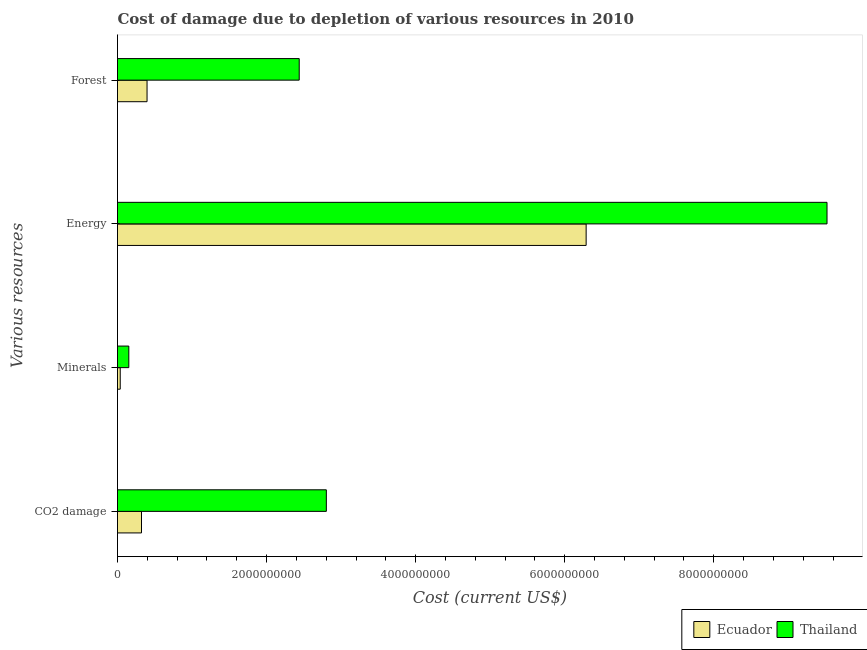How many different coloured bars are there?
Give a very brief answer. 2. How many groups of bars are there?
Offer a terse response. 4. Are the number of bars on each tick of the Y-axis equal?
Give a very brief answer. Yes. How many bars are there on the 1st tick from the top?
Provide a short and direct response. 2. What is the label of the 1st group of bars from the top?
Provide a short and direct response. Forest. What is the cost of damage due to depletion of energy in Ecuador?
Your response must be concise. 6.29e+09. Across all countries, what is the maximum cost of damage due to depletion of energy?
Provide a succinct answer. 9.52e+09. Across all countries, what is the minimum cost of damage due to depletion of forests?
Your answer should be very brief. 3.96e+08. In which country was the cost of damage due to depletion of coal maximum?
Keep it short and to the point. Thailand. In which country was the cost of damage due to depletion of energy minimum?
Offer a very short reply. Ecuador. What is the total cost of damage due to depletion of forests in the graph?
Your response must be concise. 2.83e+09. What is the difference between the cost of damage due to depletion of energy in Thailand and that in Ecuador?
Offer a terse response. 3.23e+09. What is the difference between the cost of damage due to depletion of energy in Ecuador and the cost of damage due to depletion of coal in Thailand?
Provide a succinct answer. 3.49e+09. What is the average cost of damage due to depletion of coal per country?
Provide a short and direct response. 1.56e+09. What is the difference between the cost of damage due to depletion of coal and cost of damage due to depletion of minerals in Thailand?
Ensure brevity in your answer.  2.65e+09. What is the ratio of the cost of damage due to depletion of forests in Thailand to that in Ecuador?
Your answer should be compact. 6.15. What is the difference between the highest and the second highest cost of damage due to depletion of energy?
Give a very brief answer. 3.23e+09. What is the difference between the highest and the lowest cost of damage due to depletion of forests?
Give a very brief answer. 2.04e+09. In how many countries, is the cost of damage due to depletion of coal greater than the average cost of damage due to depletion of coal taken over all countries?
Offer a terse response. 1. Is the sum of the cost of damage due to depletion of forests in Ecuador and Thailand greater than the maximum cost of damage due to depletion of coal across all countries?
Ensure brevity in your answer.  Yes. Is it the case that in every country, the sum of the cost of damage due to depletion of minerals and cost of damage due to depletion of energy is greater than the sum of cost of damage due to depletion of forests and cost of damage due to depletion of coal?
Offer a very short reply. No. What does the 1st bar from the top in Energy represents?
Give a very brief answer. Thailand. What does the 2nd bar from the bottom in Minerals represents?
Make the answer very short. Thailand. Is it the case that in every country, the sum of the cost of damage due to depletion of coal and cost of damage due to depletion of minerals is greater than the cost of damage due to depletion of energy?
Give a very brief answer. No. How many bars are there?
Provide a succinct answer. 8. Does the graph contain any zero values?
Your answer should be very brief. No. How are the legend labels stacked?
Keep it short and to the point. Horizontal. What is the title of the graph?
Offer a terse response. Cost of damage due to depletion of various resources in 2010 . Does "Namibia" appear as one of the legend labels in the graph?
Your response must be concise. No. What is the label or title of the X-axis?
Ensure brevity in your answer.  Cost (current US$). What is the label or title of the Y-axis?
Your response must be concise. Various resources. What is the Cost (current US$) in Ecuador in CO2 damage?
Offer a terse response. 3.22e+08. What is the Cost (current US$) of Thailand in CO2 damage?
Your response must be concise. 2.80e+09. What is the Cost (current US$) in Ecuador in Minerals?
Provide a short and direct response. 3.66e+07. What is the Cost (current US$) of Thailand in Minerals?
Ensure brevity in your answer.  1.52e+08. What is the Cost (current US$) in Ecuador in Energy?
Offer a very short reply. 6.29e+09. What is the Cost (current US$) of Thailand in Energy?
Provide a short and direct response. 9.52e+09. What is the Cost (current US$) in Ecuador in Forest?
Offer a terse response. 3.96e+08. What is the Cost (current US$) in Thailand in Forest?
Your response must be concise. 2.44e+09. Across all Various resources, what is the maximum Cost (current US$) in Ecuador?
Give a very brief answer. 6.29e+09. Across all Various resources, what is the maximum Cost (current US$) of Thailand?
Your response must be concise. 9.52e+09. Across all Various resources, what is the minimum Cost (current US$) of Ecuador?
Your answer should be very brief. 3.66e+07. Across all Various resources, what is the minimum Cost (current US$) of Thailand?
Make the answer very short. 1.52e+08. What is the total Cost (current US$) in Ecuador in the graph?
Offer a very short reply. 7.04e+09. What is the total Cost (current US$) of Thailand in the graph?
Your answer should be very brief. 1.49e+1. What is the difference between the Cost (current US$) in Ecuador in CO2 damage and that in Minerals?
Provide a succinct answer. 2.85e+08. What is the difference between the Cost (current US$) of Thailand in CO2 damage and that in Minerals?
Ensure brevity in your answer.  2.65e+09. What is the difference between the Cost (current US$) of Ecuador in CO2 damage and that in Energy?
Offer a terse response. -5.97e+09. What is the difference between the Cost (current US$) of Thailand in CO2 damage and that in Energy?
Offer a very short reply. -6.72e+09. What is the difference between the Cost (current US$) in Ecuador in CO2 damage and that in Forest?
Give a very brief answer. -7.45e+07. What is the difference between the Cost (current US$) in Thailand in CO2 damage and that in Forest?
Offer a very short reply. 3.64e+08. What is the difference between the Cost (current US$) in Ecuador in Minerals and that in Energy?
Provide a succinct answer. -6.25e+09. What is the difference between the Cost (current US$) in Thailand in Minerals and that in Energy?
Ensure brevity in your answer.  -9.37e+09. What is the difference between the Cost (current US$) in Ecuador in Minerals and that in Forest?
Your answer should be compact. -3.60e+08. What is the difference between the Cost (current US$) of Thailand in Minerals and that in Forest?
Make the answer very short. -2.29e+09. What is the difference between the Cost (current US$) in Ecuador in Energy and that in Forest?
Offer a very short reply. 5.89e+09. What is the difference between the Cost (current US$) of Thailand in Energy and that in Forest?
Give a very brief answer. 7.08e+09. What is the difference between the Cost (current US$) in Ecuador in CO2 damage and the Cost (current US$) in Thailand in Minerals?
Give a very brief answer. 1.70e+08. What is the difference between the Cost (current US$) of Ecuador in CO2 damage and the Cost (current US$) of Thailand in Energy?
Your answer should be compact. -9.20e+09. What is the difference between the Cost (current US$) in Ecuador in CO2 damage and the Cost (current US$) in Thailand in Forest?
Your response must be concise. -2.12e+09. What is the difference between the Cost (current US$) of Ecuador in Minerals and the Cost (current US$) of Thailand in Energy?
Ensure brevity in your answer.  -9.48e+09. What is the difference between the Cost (current US$) of Ecuador in Minerals and the Cost (current US$) of Thailand in Forest?
Keep it short and to the point. -2.40e+09. What is the difference between the Cost (current US$) of Ecuador in Energy and the Cost (current US$) of Thailand in Forest?
Ensure brevity in your answer.  3.85e+09. What is the average Cost (current US$) of Ecuador per Various resources?
Give a very brief answer. 1.76e+09. What is the average Cost (current US$) in Thailand per Various resources?
Ensure brevity in your answer.  3.73e+09. What is the difference between the Cost (current US$) in Ecuador and Cost (current US$) in Thailand in CO2 damage?
Ensure brevity in your answer.  -2.48e+09. What is the difference between the Cost (current US$) of Ecuador and Cost (current US$) of Thailand in Minerals?
Your answer should be compact. -1.15e+08. What is the difference between the Cost (current US$) in Ecuador and Cost (current US$) in Thailand in Energy?
Your answer should be compact. -3.23e+09. What is the difference between the Cost (current US$) of Ecuador and Cost (current US$) of Thailand in Forest?
Offer a terse response. -2.04e+09. What is the ratio of the Cost (current US$) of Ecuador in CO2 damage to that in Minerals?
Your answer should be very brief. 8.8. What is the ratio of the Cost (current US$) in Thailand in CO2 damage to that in Minerals?
Give a very brief answer. 18.46. What is the ratio of the Cost (current US$) in Ecuador in CO2 damage to that in Energy?
Offer a very short reply. 0.05. What is the ratio of the Cost (current US$) of Thailand in CO2 damage to that in Energy?
Provide a succinct answer. 0.29. What is the ratio of the Cost (current US$) in Ecuador in CO2 damage to that in Forest?
Give a very brief answer. 0.81. What is the ratio of the Cost (current US$) of Thailand in CO2 damage to that in Forest?
Your response must be concise. 1.15. What is the ratio of the Cost (current US$) of Ecuador in Minerals to that in Energy?
Your answer should be compact. 0.01. What is the ratio of the Cost (current US$) in Thailand in Minerals to that in Energy?
Keep it short and to the point. 0.02. What is the ratio of the Cost (current US$) of Ecuador in Minerals to that in Forest?
Offer a terse response. 0.09. What is the ratio of the Cost (current US$) in Thailand in Minerals to that in Forest?
Your answer should be compact. 0.06. What is the ratio of the Cost (current US$) in Ecuador in Energy to that in Forest?
Offer a terse response. 15.86. What is the ratio of the Cost (current US$) in Thailand in Energy to that in Forest?
Keep it short and to the point. 3.9. What is the difference between the highest and the second highest Cost (current US$) of Ecuador?
Your response must be concise. 5.89e+09. What is the difference between the highest and the second highest Cost (current US$) in Thailand?
Your response must be concise. 6.72e+09. What is the difference between the highest and the lowest Cost (current US$) of Ecuador?
Give a very brief answer. 6.25e+09. What is the difference between the highest and the lowest Cost (current US$) of Thailand?
Provide a short and direct response. 9.37e+09. 